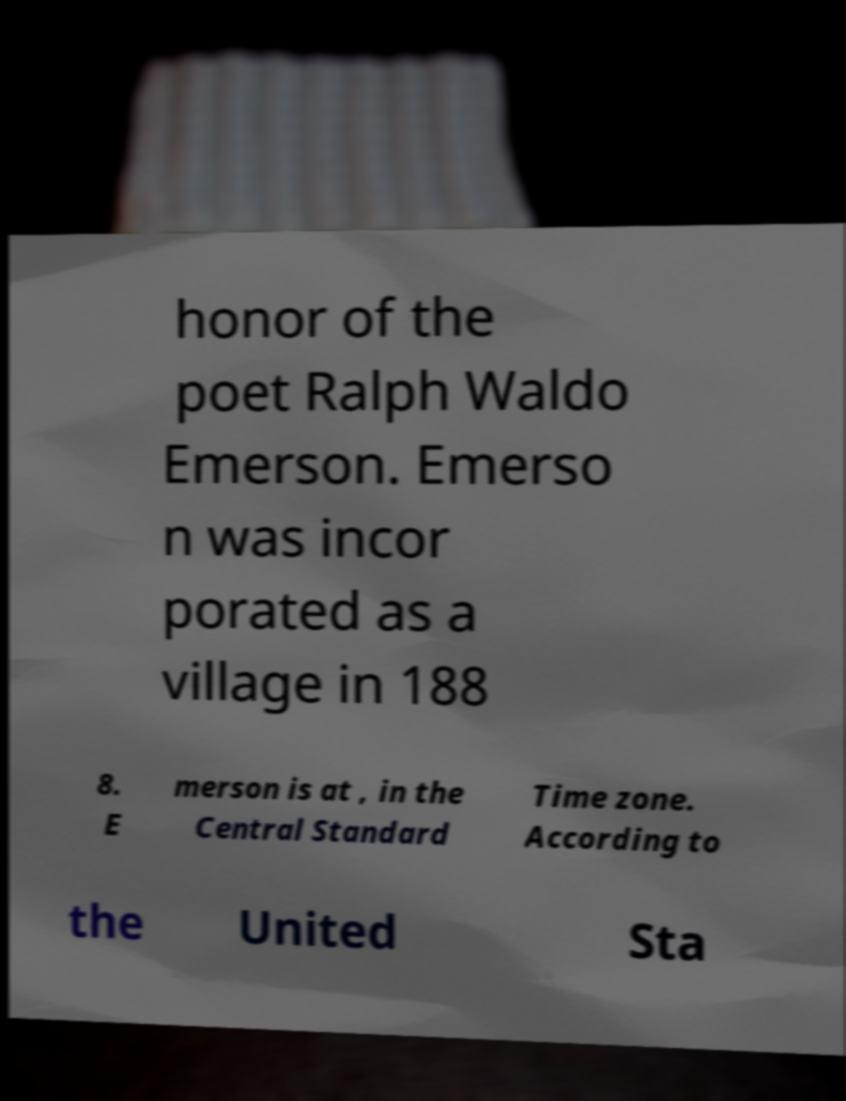Please read and relay the text visible in this image. What does it say? honor of the poet Ralph Waldo Emerson. Emerso n was incor porated as a village in 188 8. E merson is at , in the Central Standard Time zone. According to the United Sta 